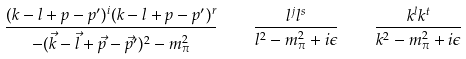<formula> <loc_0><loc_0><loc_500><loc_500>\frac { ( k - l + p - p ^ { \prime } ) ^ { i } ( k - l + p - p ^ { \prime } ) ^ { r } } { - ( \vec { k } - \vec { l } + \vec { p } - \vec { p } ^ { \prime } ) ^ { 2 } - m _ { \pi } ^ { 2 } } \quad \frac { l ^ { j } l ^ { s } } { l ^ { 2 } - m _ { \pi } ^ { 2 } + i \epsilon } \quad \frac { k ^ { l } k ^ { t } } { k ^ { 2 } - m _ { \pi } ^ { 2 } + i \epsilon }</formula> 